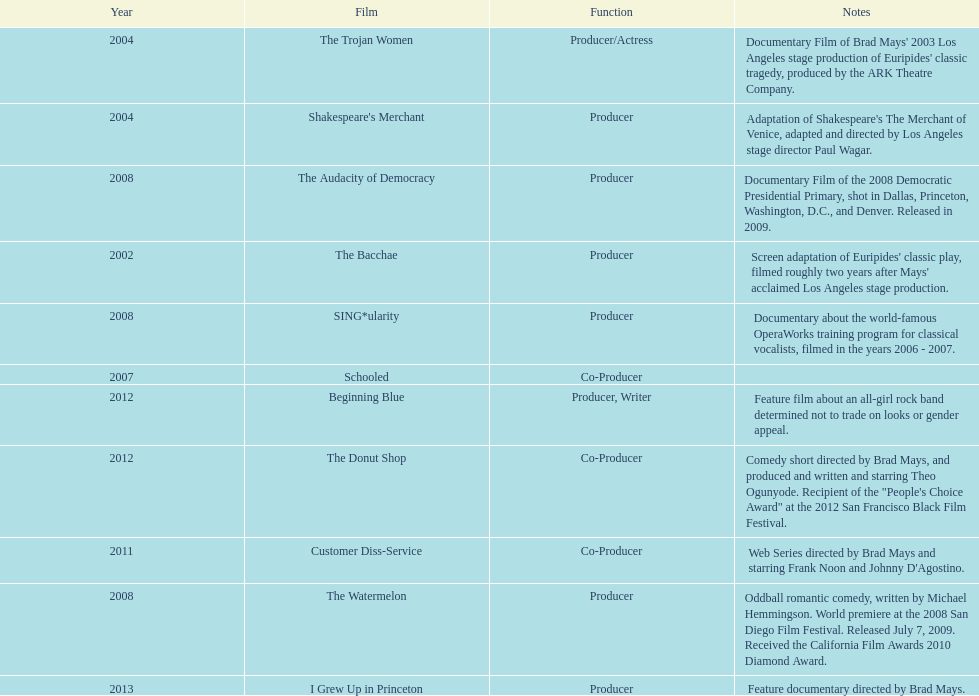In what year did ms. starfelt create the highest number of movies? 2008. 